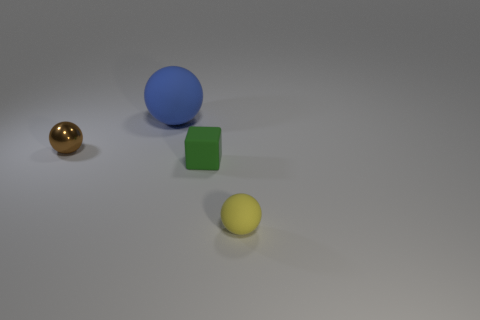Do the rubber sphere on the right side of the block and the tiny brown thing have the same size?
Provide a short and direct response. Yes. There is a block that is the same material as the yellow thing; what is its size?
Keep it short and to the point. Small. Are there more brown metal objects that are in front of the small yellow ball than large blue matte objects left of the big sphere?
Make the answer very short. No. What number of other objects are the same material as the blue sphere?
Keep it short and to the point. 2. Is the object left of the big blue ball made of the same material as the tiny green block?
Ensure brevity in your answer.  No. The brown object is what shape?
Ensure brevity in your answer.  Sphere. Is the number of big matte spheres that are in front of the tiny metal thing greater than the number of large things?
Your answer should be compact. No. Is there anything else that has the same shape as the small green thing?
Your answer should be compact. No. What is the color of the other tiny thing that is the same shape as the brown object?
Make the answer very short. Yellow. What shape is the small matte object on the left side of the small yellow thing?
Your answer should be very brief. Cube. 